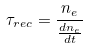<formula> <loc_0><loc_0><loc_500><loc_500>\tau _ { r e c } = \frac { n _ { e } } { \frac { d n _ { e } } { d t } }</formula> 